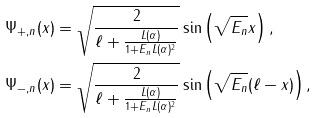Convert formula to latex. <formula><loc_0><loc_0><loc_500><loc_500>\Psi _ { + , n } ( x ) & = \sqrt { \frac { 2 } { \ell + \frac { L ( \alpha ) } { 1 + E _ { n } L ( \alpha ) ^ { 2 } } } } \sin \left ( \sqrt { E _ { n } } x \right ) , \\ \Psi _ { - , n } ( x ) & = \sqrt { \frac { 2 } { \ell + \frac { L ( \alpha ) } { 1 + E _ { n } L ( \alpha ) ^ { 2 } } } } \sin \left ( \sqrt { E _ { n } } ( \ell - x ) \right ) ,</formula> 